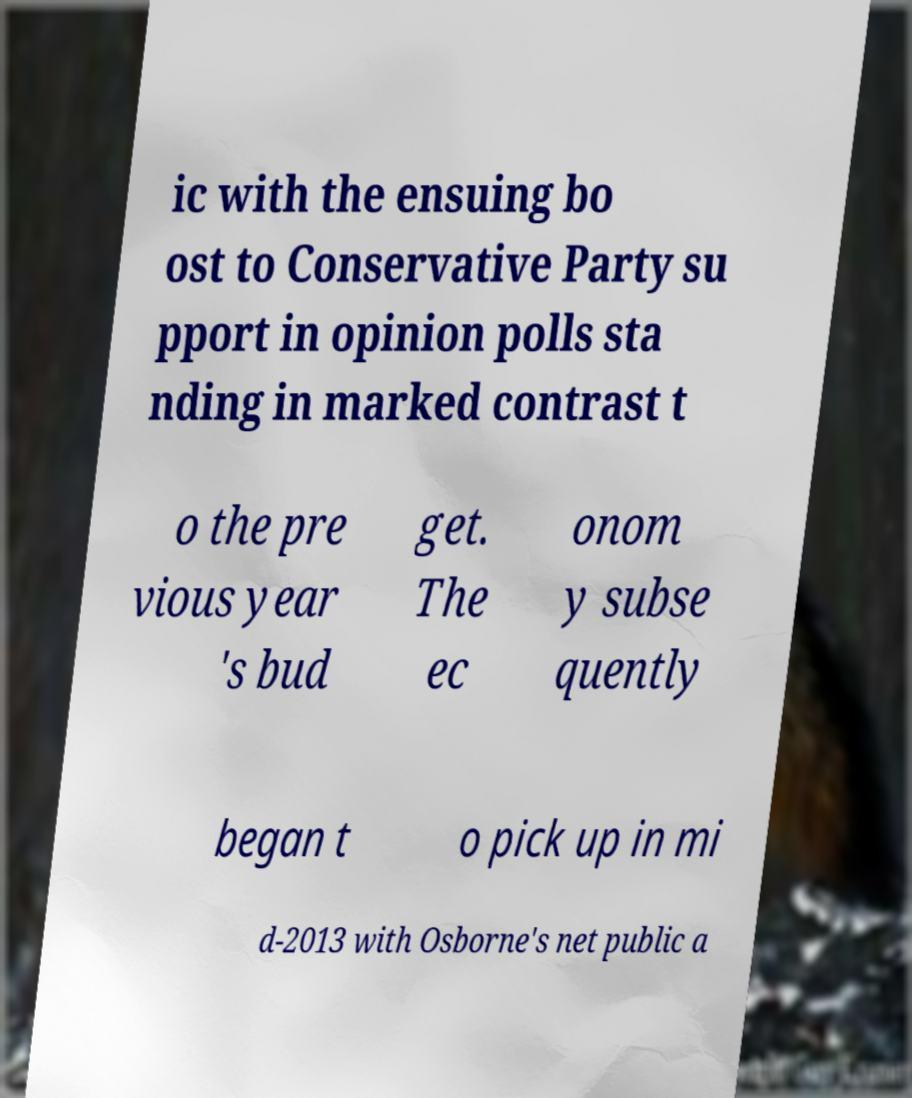Please identify and transcribe the text found in this image. ic with the ensuing bo ost to Conservative Party su pport in opinion polls sta nding in marked contrast t o the pre vious year 's bud get. The ec onom y subse quently began t o pick up in mi d-2013 with Osborne's net public a 